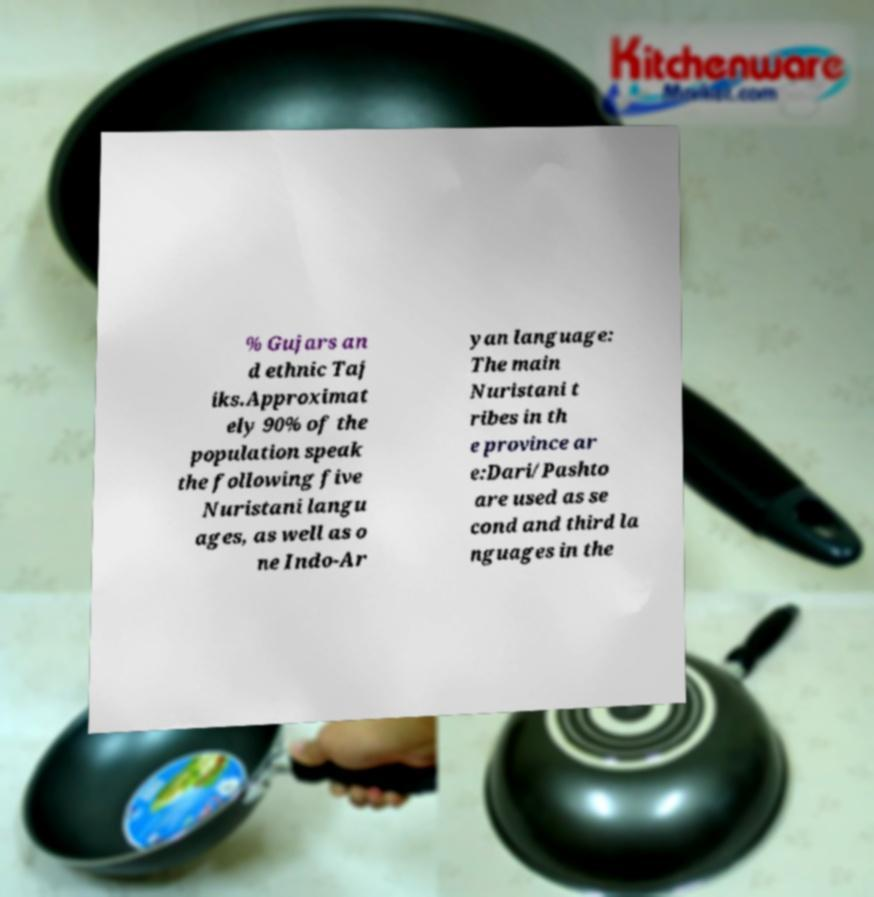For documentation purposes, I need the text within this image transcribed. Could you provide that? % Gujars an d ethnic Taj iks.Approximat ely 90% of the population speak the following five Nuristani langu ages, as well as o ne Indo-Ar yan language: The main Nuristani t ribes in th e province ar e:Dari/Pashto are used as se cond and third la nguages in the 